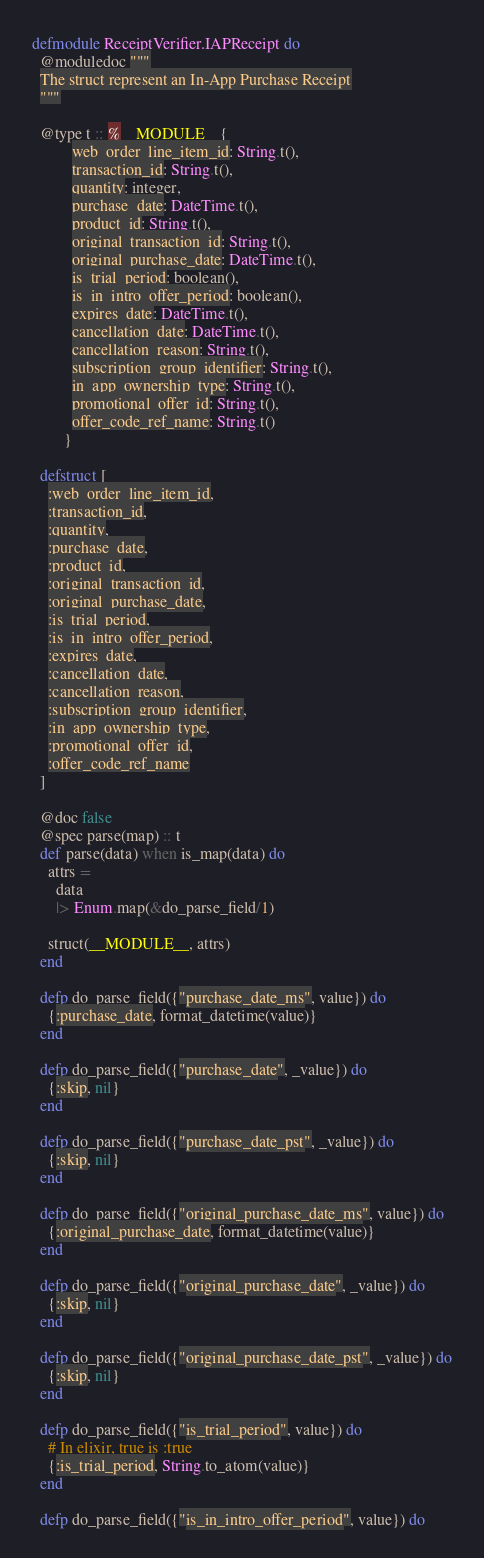Convert code to text. <code><loc_0><loc_0><loc_500><loc_500><_Elixir_>defmodule ReceiptVerifier.IAPReceipt do
  @moduledoc """
  The struct represent an In-App Purchase Receipt
  """

  @type t :: %__MODULE__{
          web_order_line_item_id: String.t(),
          transaction_id: String.t(),
          quantity: integer,
          purchase_date: DateTime.t(),
          product_id: String.t(),
          original_transaction_id: String.t(),
          original_purchase_date: DateTime.t(),
          is_trial_period: boolean(),
          is_in_intro_offer_period: boolean(),
          expires_date: DateTime.t(),
          cancellation_date: DateTime.t(),
          cancellation_reason: String.t(),
          subscription_group_identifier: String.t(),
          in_app_ownership_type: String.t(),
          promotional_offer_id: String.t(),
          offer_code_ref_name: String.t()
        }

  defstruct [
    :web_order_line_item_id,
    :transaction_id,
    :quantity,
    :purchase_date,
    :product_id,
    :original_transaction_id,
    :original_purchase_date,
    :is_trial_period,
    :is_in_intro_offer_period,
    :expires_date,
    :cancellation_date,
    :cancellation_reason,
    :subscription_group_identifier,
    :in_app_ownership_type,
    :promotional_offer_id,
    :offer_code_ref_name
  ]

  @doc false
  @spec parse(map) :: t
  def parse(data) when is_map(data) do
    attrs =
      data
      |> Enum.map(&do_parse_field/1)

    struct(__MODULE__, attrs)
  end

  defp do_parse_field({"purchase_date_ms", value}) do
    {:purchase_date, format_datetime(value)}
  end

  defp do_parse_field({"purchase_date", _value}) do
    {:skip, nil}
  end

  defp do_parse_field({"purchase_date_pst", _value}) do
    {:skip, nil}
  end

  defp do_parse_field({"original_purchase_date_ms", value}) do
    {:original_purchase_date, format_datetime(value)}
  end

  defp do_parse_field({"original_purchase_date", _value}) do
    {:skip, nil}
  end

  defp do_parse_field({"original_purchase_date_pst", _value}) do
    {:skip, nil}
  end

  defp do_parse_field({"is_trial_period", value}) do
    # In elixir, true is :true
    {:is_trial_period, String.to_atom(value)}
  end

  defp do_parse_field({"is_in_intro_offer_period", value}) do</code> 